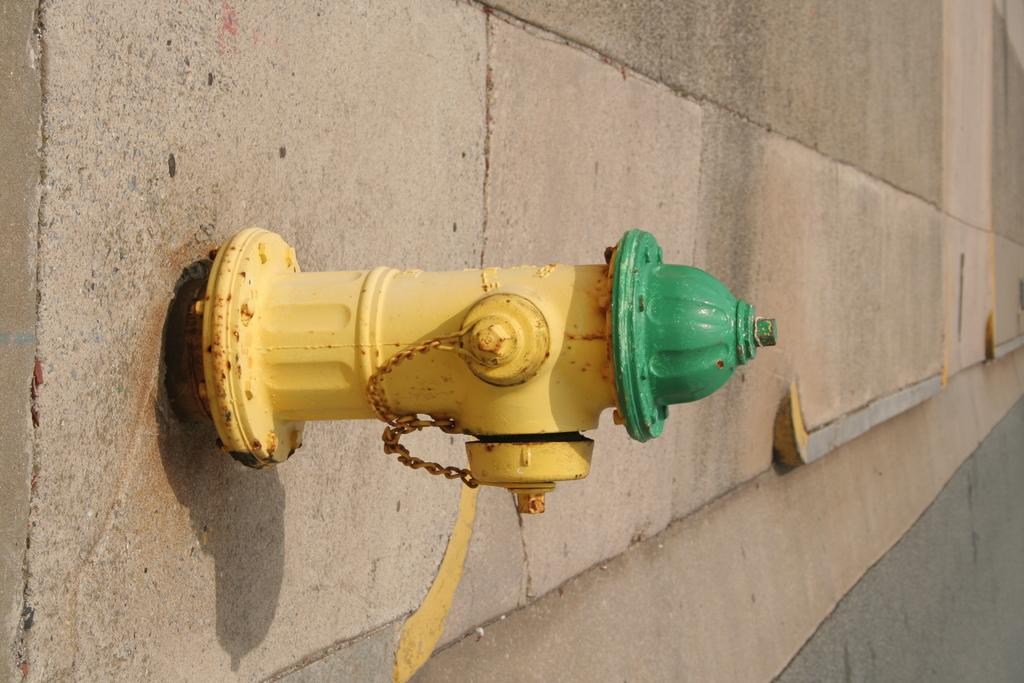What object can be seen on the floor in the image? There is a fire hydrant on the floor in the image. What type of popcorn is being served at the science event in the image? There is no popcorn, science event, or any reference to serving in the image. The image only shows a fire hydrant on the floor. 